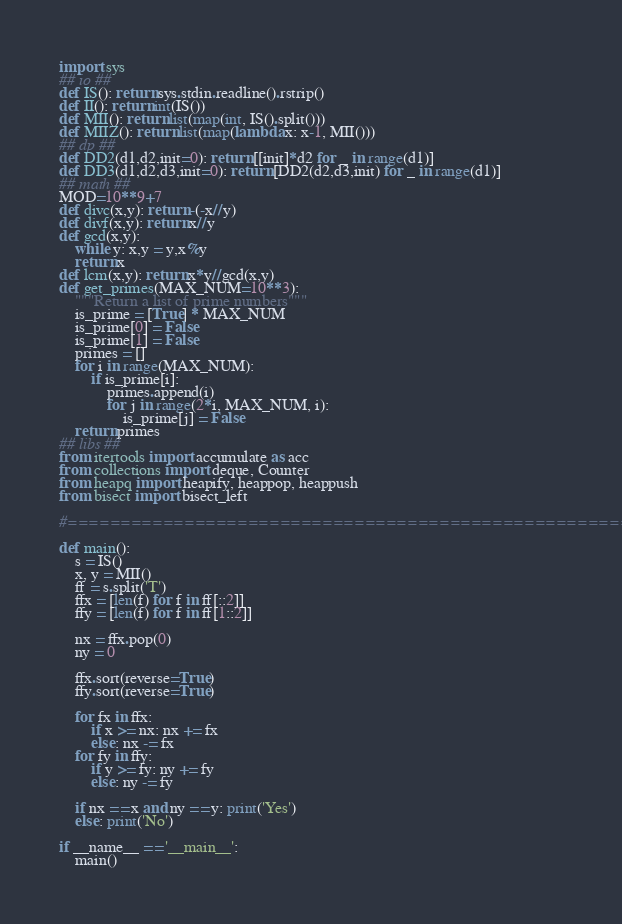<code> <loc_0><loc_0><loc_500><loc_500><_Python_>import sys
## io ##
def IS(): return sys.stdin.readline().rstrip()
def II(): return int(IS())
def MII(): return list(map(int, IS().split()))
def MIIZ(): return list(map(lambda x: x-1, MII()))
## dp ##
def DD2(d1,d2,init=0): return [[init]*d2 for _ in range(d1)]
def DD3(d1,d2,d3,init=0): return [DD2(d2,d3,init) for _ in range(d1)]
## math ##
MOD=10**9+7
def divc(x,y): return -(-x//y)
def divf(x,y): return x//y
def gcd(x,y):
    while y: x,y = y,x%y
    return x
def lcm(x,y): return x*y//gcd(x,y)
def get_primes(MAX_NUM=10**3):
    """Return a list of prime numbers"""
    is_prime = [True] * MAX_NUM
    is_prime[0] = False
    is_prime[1] = False
    primes = []
    for i in range(MAX_NUM):
        if is_prime[i]:
            primes.append(i)
            for j in range(2*i, MAX_NUM, i):
                is_prime[j] = False
    return primes
## libs ##
from itertools import accumulate as acc
from collections import deque, Counter
from heapq import heapify, heappop, heappush
from bisect import bisect_left

#======================================================#

def main():
    s = IS()
    x, y = MII()
    ff = s.split('T')
    ffx = [len(f) for f in ff[::2]]
    ffy = [len(f) for f in ff[1::2]]

    nx = ffx.pop(0)
    ny = 0

    ffx.sort(reverse=True)
    ffy.sort(reverse=True)

    for fx in ffx:
        if x >= nx: nx += fx
        else: nx -= fx
    for fy in ffy:
        if y >= fy: ny += fy
        else: ny -= fy

    if nx == x and ny == y: print('Yes')
    else: print('No')

if __name__ == '__main__':
    main()</code> 